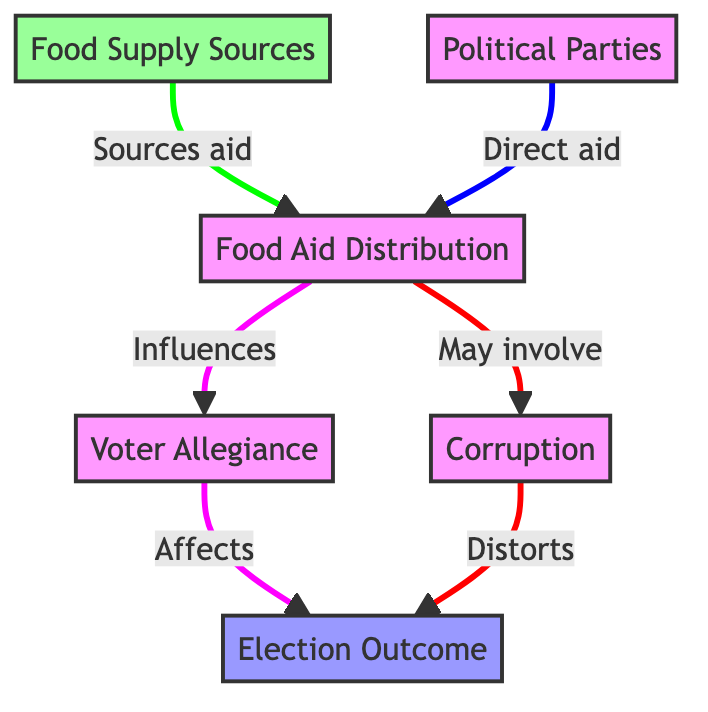What is the source of food aid? The diagram indicates that food supply sources are the origin of the food aid distributed during elections.
Answer: Food Supply Sources How many relationships are shown in the diagram? By counting the arrows connecting different nodes, there are five distinct relationships represented in the diagram.
Answer: Five Which node is influenced by food aid distribution? The diagram shows that voter allegiance is directly influenced by food aid distribution.
Answer: Voter Allegiance What is the outcome of voter allegiance? According to the diagram, the outcome affected by voter allegiance is the election outcome.
Answer: Election Outcome What may be involved in food aid distribution? The diagram indicates that corruption may be involved in the process of food aid distribution.
Answer: Corruption How does corruption affect the election outcome? The flow of the diagram specifies that corruption distorts the final election outcome.
Answer: Distorts Which two sources provide food aid to the distribution node? The diagram explicitly states that food supply sources and political parties provide food aid to the distribution node.
Answer: Food Supply Sources and Political Parties What happens if food aid distribution influences voter allegiance? The influence of food aid distribution on voter allegiance directly impacts the election outcome, as per the flow of the diagram.
Answer: Affects Election Outcome Which node represents a source of corruption within the aid distribution process? Corruption is labeled in the diagram as a potential consequence arising from food aid distribution.
Answer: Corruption 